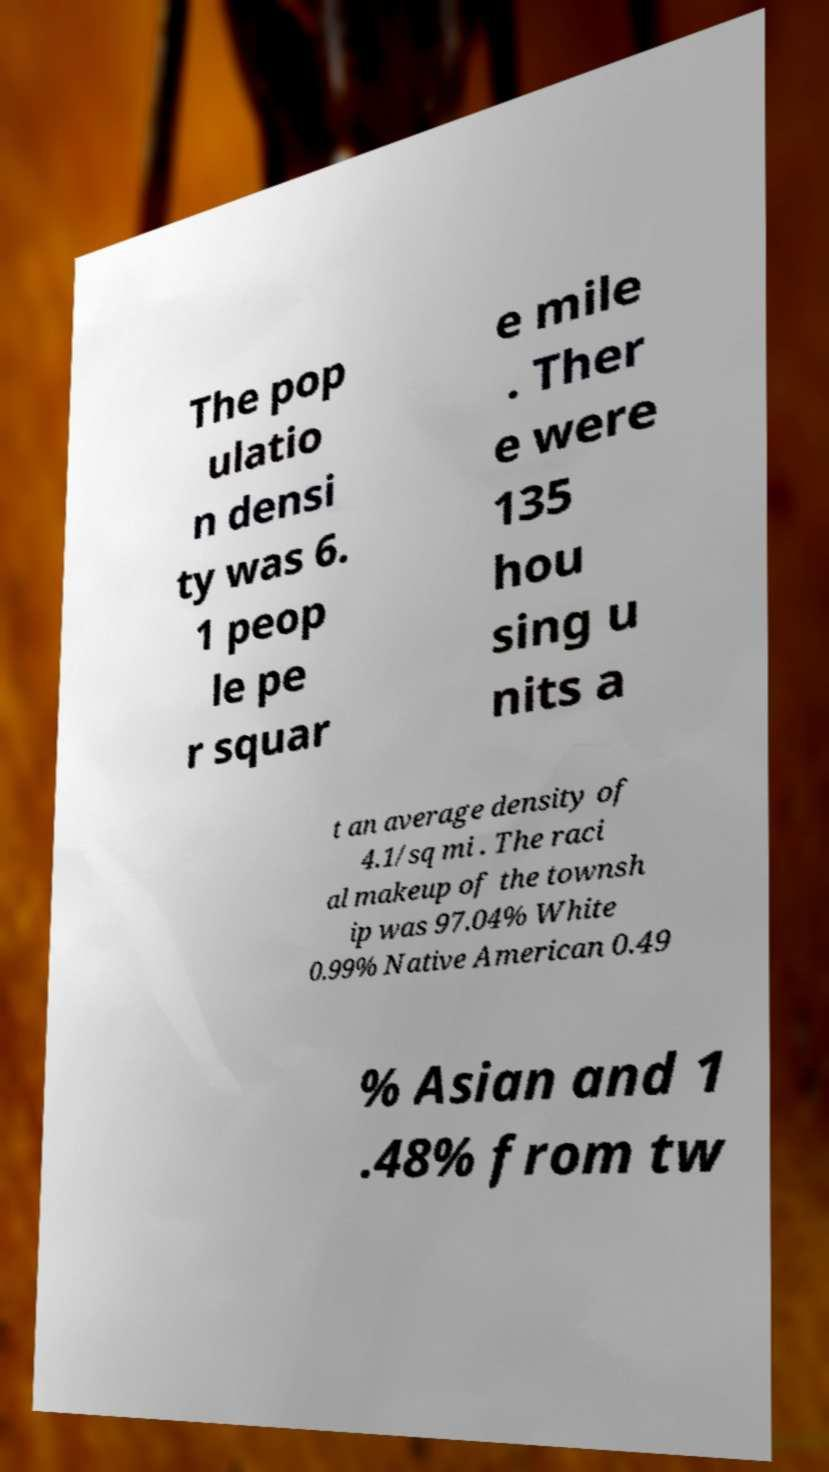I need the written content from this picture converted into text. Can you do that? The pop ulatio n densi ty was 6. 1 peop le pe r squar e mile . Ther e were 135 hou sing u nits a t an average density of 4.1/sq mi . The raci al makeup of the townsh ip was 97.04% White 0.99% Native American 0.49 % Asian and 1 .48% from tw 